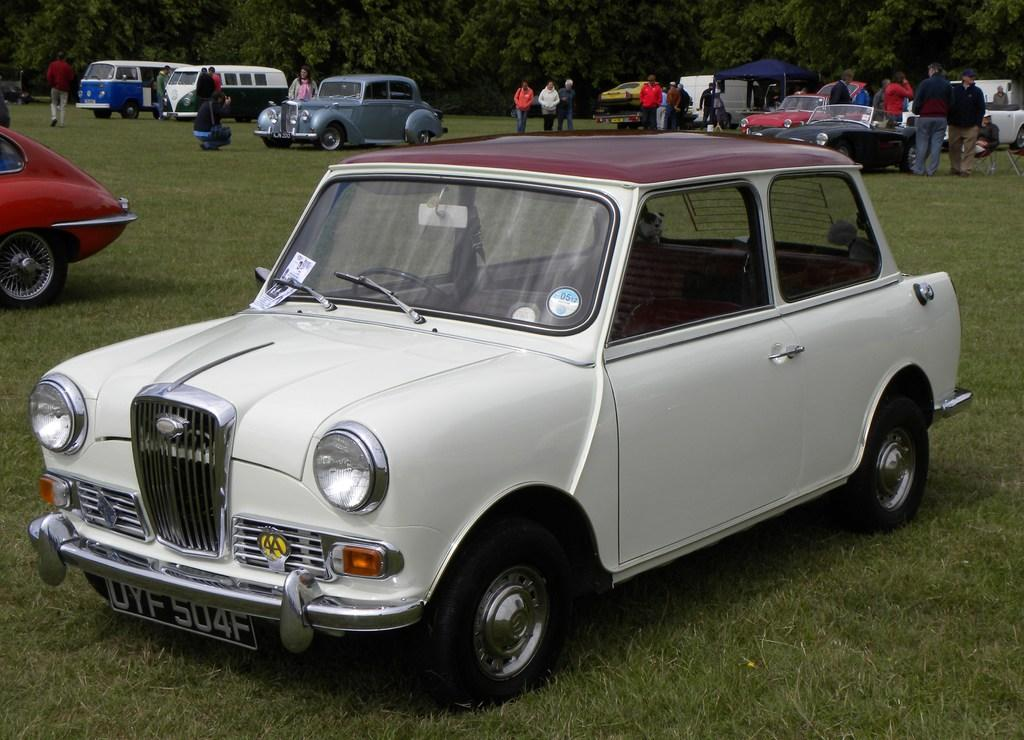What can be seen in large numbers in the image? There are many vehicles and people in the image. What is the ground surface like in the image? There is grass on the ground in the image. What type of natural scenery is visible in the background? There are trees in the background of the image. What type of boot is being worn by the people in the image? There is no mention of boots or footwear in the image, so it cannot be determined what type of boot the people might be wearing. 